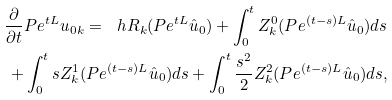<formula> <loc_0><loc_0><loc_500><loc_500>\frac { \partial } { \partial { t } } P e ^ { t L } u _ { 0 k } = \ h R _ { k } ( P e ^ { t L } \hat { u } _ { 0 } ) + \int _ { 0 } ^ { t } Z ^ { 0 } _ { k } ( P e ^ { ( t - s ) L } \hat { u } _ { 0 } ) d s \\ + \int _ { 0 } ^ { t } s Z ^ { 1 } _ { k } ( P e ^ { ( t - s ) L } \hat { u } _ { 0 } ) d s + \int _ { 0 } ^ { t } \frac { s ^ { 2 } } { 2 } Z ^ { 2 } _ { k } ( P e ^ { ( t - s ) L } \hat { u } _ { 0 } ) d s ,</formula> 